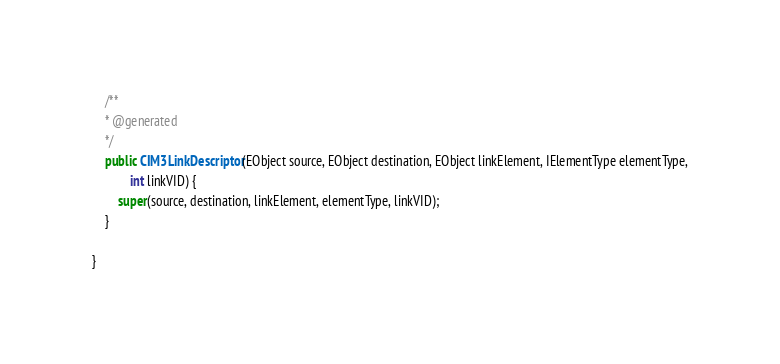<code> <loc_0><loc_0><loc_500><loc_500><_Java_>	/**
	* @generated
	*/
	public CIM3LinkDescriptor(EObject source, EObject destination, EObject linkElement, IElementType elementType,
			int linkVID) {
		super(source, destination, linkElement, elementType, linkVID);
	}

}
</code> 